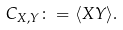Convert formula to latex. <formula><loc_0><loc_0><loc_500><loc_500>C _ { X , Y } \colon = \langle X Y \rangle .</formula> 